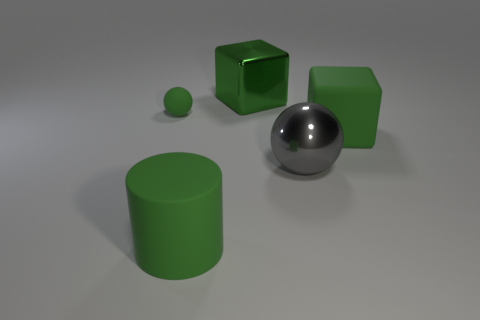Could you describe the lighting and shadows in the scene? The lighting in the scene appears to be coming from the upper left side, judging by the direction and length of the shadows cast by the objects. The shadows are soft-edged, which suggests a diffused light source, creating a gentle illumination over the whole scene. 